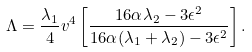<formula> <loc_0><loc_0><loc_500><loc_500>\Lambda = { \frac { \lambda _ { 1 } } { 4 } } v ^ { 4 } \left [ { \frac { 1 6 \alpha \lambda _ { 2 } - 3 \epsilon ^ { 2 } } { 1 6 \alpha ( \lambda _ { 1 } + \lambda _ { 2 } ) - 3 \epsilon ^ { 2 } } } \right ] .</formula> 